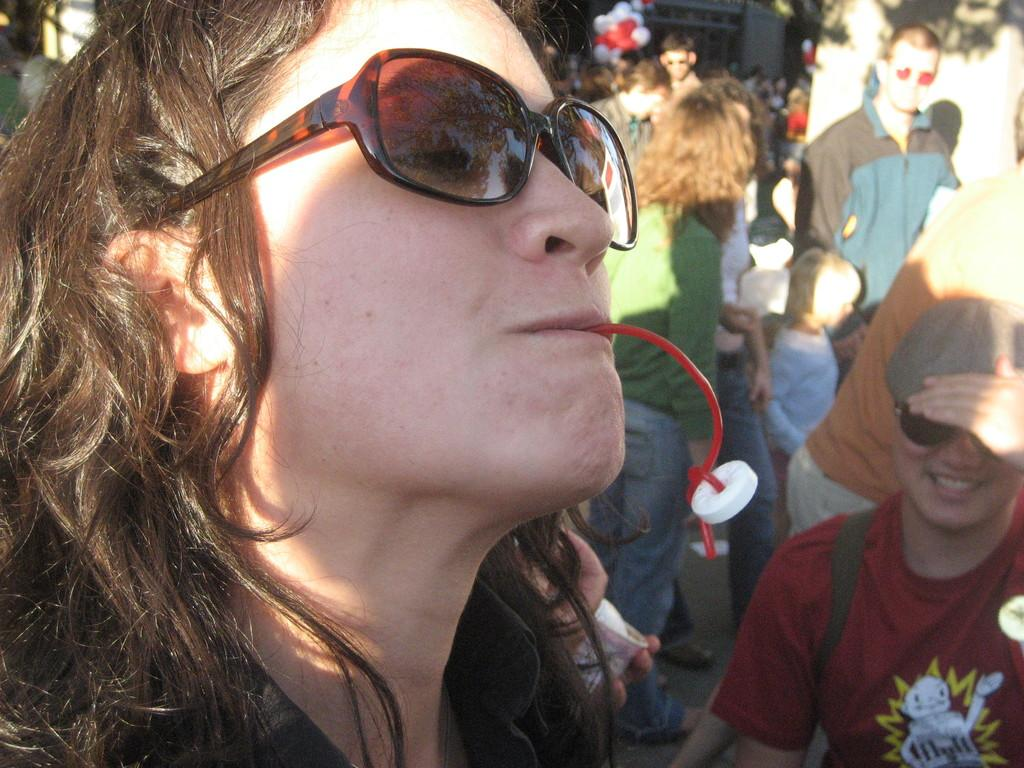How many people are in the image? There is a group of persons standing in the image. Can you describe the appearance of one of the persons in the image? A woman is wearing goggles in the image. What is the woman doing with her mouth in the image? The woman has something in her mouth in the image. What is the woman writing on the paper in the image? There is no paper or writing activity present in the image. 